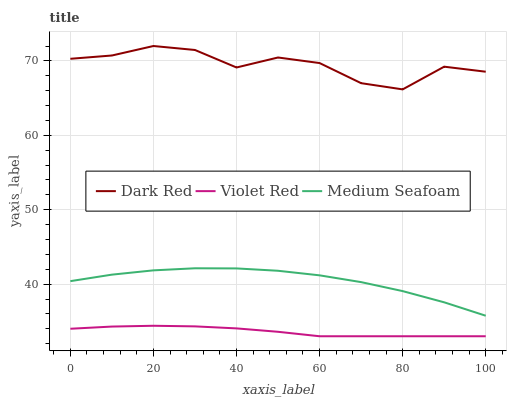Does Violet Red have the minimum area under the curve?
Answer yes or no. Yes. Does Dark Red have the maximum area under the curve?
Answer yes or no. Yes. Does Medium Seafoam have the minimum area under the curve?
Answer yes or no. No. Does Medium Seafoam have the maximum area under the curve?
Answer yes or no. No. Is Violet Red the smoothest?
Answer yes or no. Yes. Is Dark Red the roughest?
Answer yes or no. Yes. Is Medium Seafoam the smoothest?
Answer yes or no. No. Is Medium Seafoam the roughest?
Answer yes or no. No. Does Violet Red have the lowest value?
Answer yes or no. Yes. Does Medium Seafoam have the lowest value?
Answer yes or no. No. Does Dark Red have the highest value?
Answer yes or no. Yes. Does Medium Seafoam have the highest value?
Answer yes or no. No. Is Violet Red less than Dark Red?
Answer yes or no. Yes. Is Medium Seafoam greater than Violet Red?
Answer yes or no. Yes. Does Violet Red intersect Dark Red?
Answer yes or no. No. 